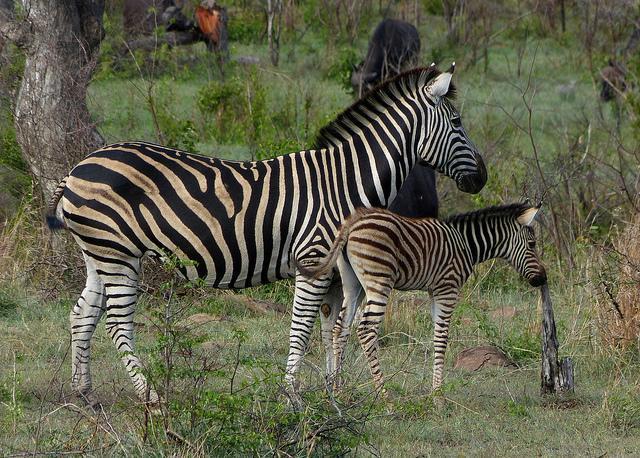How many zebras are in the picture?
Give a very brief answer. 2. How many zebras are there?
Give a very brief answer. 2. How many suitcases are shown?
Give a very brief answer. 0. 